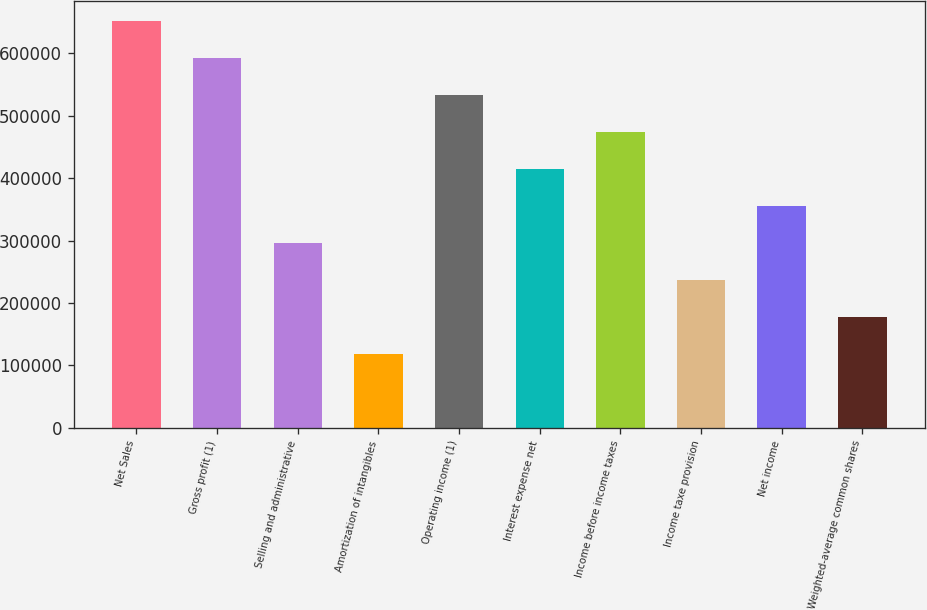<chart> <loc_0><loc_0><loc_500><loc_500><bar_chart><fcel>Net Sales<fcel>Gross profit (1)<fcel>Selling and administrative<fcel>Amortization of intangibles<fcel>Operating income (1)<fcel>Interest expense net<fcel>Income before income taxes<fcel>Income taxe provision<fcel>Net income<fcel>Weighted-average common shares<nl><fcel>652078<fcel>592798<fcel>296400<fcel>118561<fcel>533518<fcel>414959<fcel>474239<fcel>237120<fcel>355680<fcel>177841<nl></chart> 